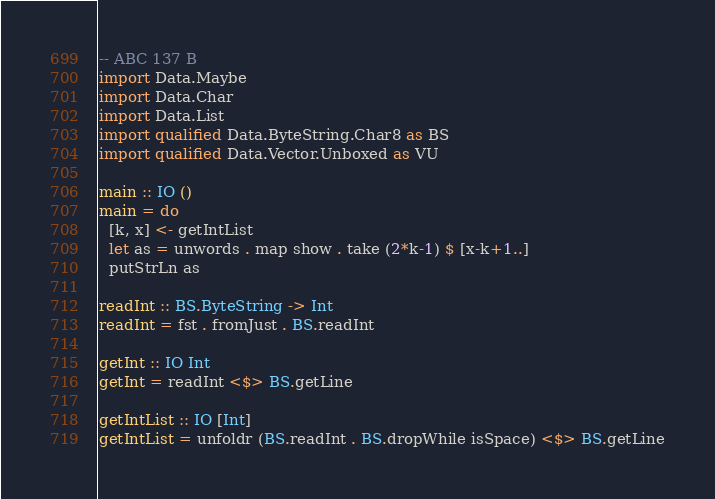Convert code to text. <code><loc_0><loc_0><loc_500><loc_500><_Haskell_>-- ABC 137 B
import Data.Maybe
import Data.Char
import Data.List
import qualified Data.ByteString.Char8 as BS
import qualified Data.Vector.Unboxed as VU

main :: IO ()
main = do
  [k, x] <- getIntList
  let as = unwords . map show . take (2*k-1) $ [x-k+1..]
  putStrLn as

readInt :: BS.ByteString -> Int
readInt = fst . fromJust . BS.readInt

getInt :: IO Int
getInt = readInt <$> BS.getLine

getIntList :: IO [Int]
getIntList = unfoldr (BS.readInt . BS.dropWhile isSpace) <$> BS.getLine</code> 